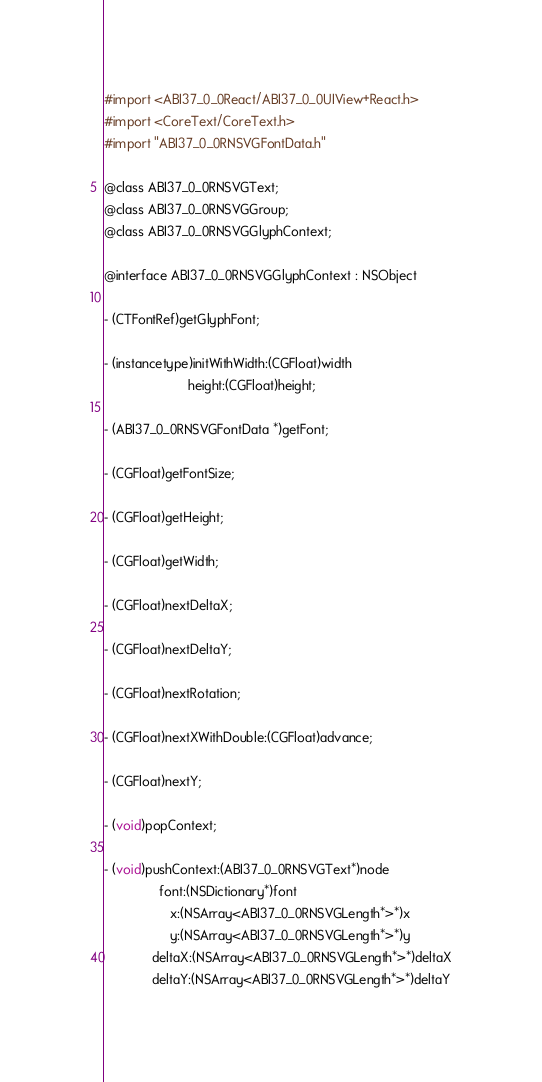Convert code to text. <code><loc_0><loc_0><loc_500><loc_500><_C_>#import <ABI37_0_0React/ABI37_0_0UIView+React.h>
#import <CoreText/CoreText.h>
#import "ABI37_0_0RNSVGFontData.h"

@class ABI37_0_0RNSVGText;
@class ABI37_0_0RNSVGGroup;
@class ABI37_0_0RNSVGGlyphContext;

@interface ABI37_0_0RNSVGGlyphContext : NSObject

- (CTFontRef)getGlyphFont;

- (instancetype)initWithWidth:(CGFloat)width
                       height:(CGFloat)height;

- (ABI37_0_0RNSVGFontData *)getFont;

- (CGFloat)getFontSize;

- (CGFloat)getHeight;

- (CGFloat)getWidth;

- (CGFloat)nextDeltaX;

- (CGFloat)nextDeltaY;

- (CGFloat)nextRotation;

- (CGFloat)nextXWithDouble:(CGFloat)advance;

- (CGFloat)nextY;

- (void)popContext;

- (void)pushContext:(ABI37_0_0RNSVGText*)node
               font:(NSDictionary*)font
                  x:(NSArray<ABI37_0_0RNSVGLength*>*)x
                  y:(NSArray<ABI37_0_0RNSVGLength*>*)y
             deltaX:(NSArray<ABI37_0_0RNSVGLength*>*)deltaX
             deltaY:(NSArray<ABI37_0_0RNSVGLength*>*)deltaY</code> 